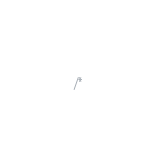<code> <loc_0><loc_0><loc_500><loc_500><_C++_>/*</code> 